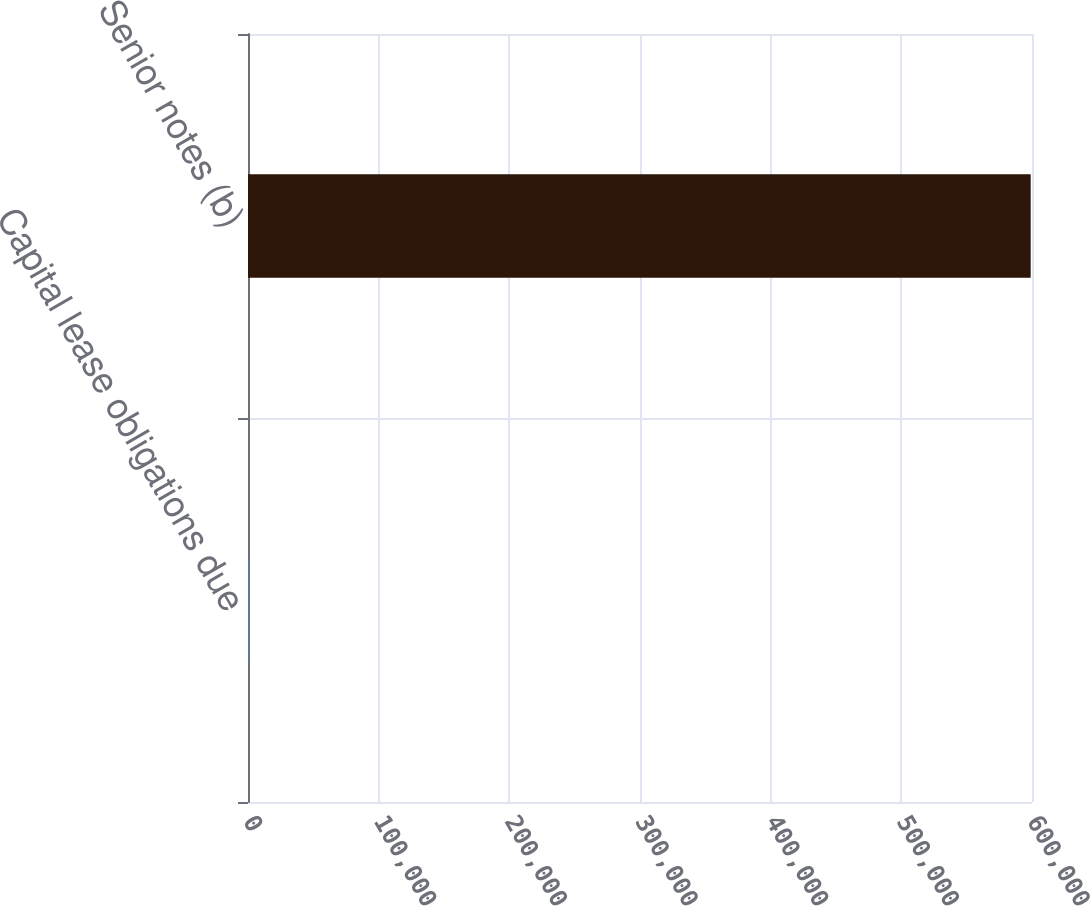Convert chart. <chart><loc_0><loc_0><loc_500><loc_500><bar_chart><fcel>Capital lease obligations due<fcel>Senior notes (b)<nl><fcel>757<fcel>598988<nl></chart> 